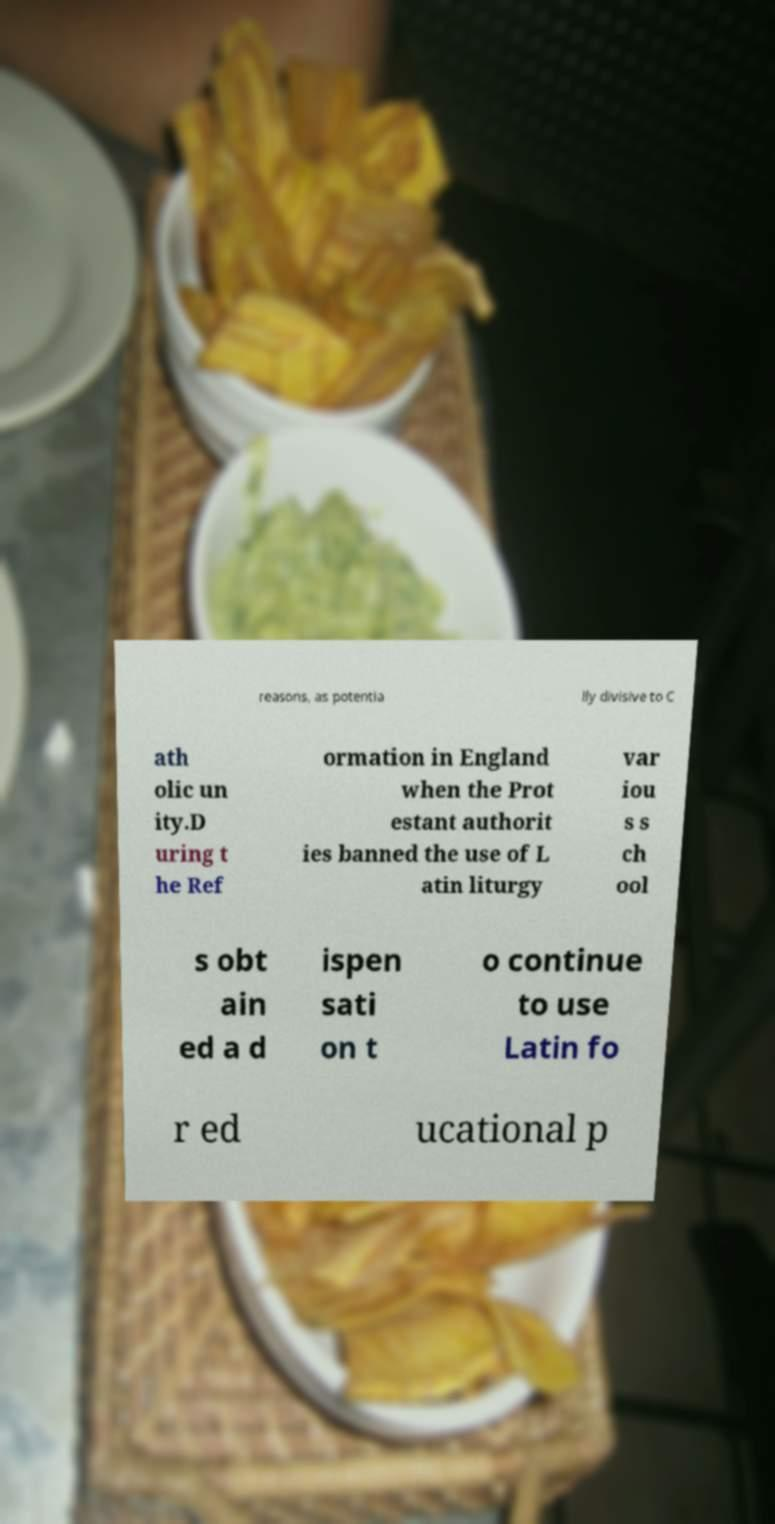Please read and relay the text visible in this image. What does it say? reasons, as potentia lly divisive to C ath olic un ity.D uring t he Ref ormation in England when the Prot estant authorit ies banned the use of L atin liturgy var iou s s ch ool s obt ain ed a d ispen sati on t o continue to use Latin fo r ed ucational p 